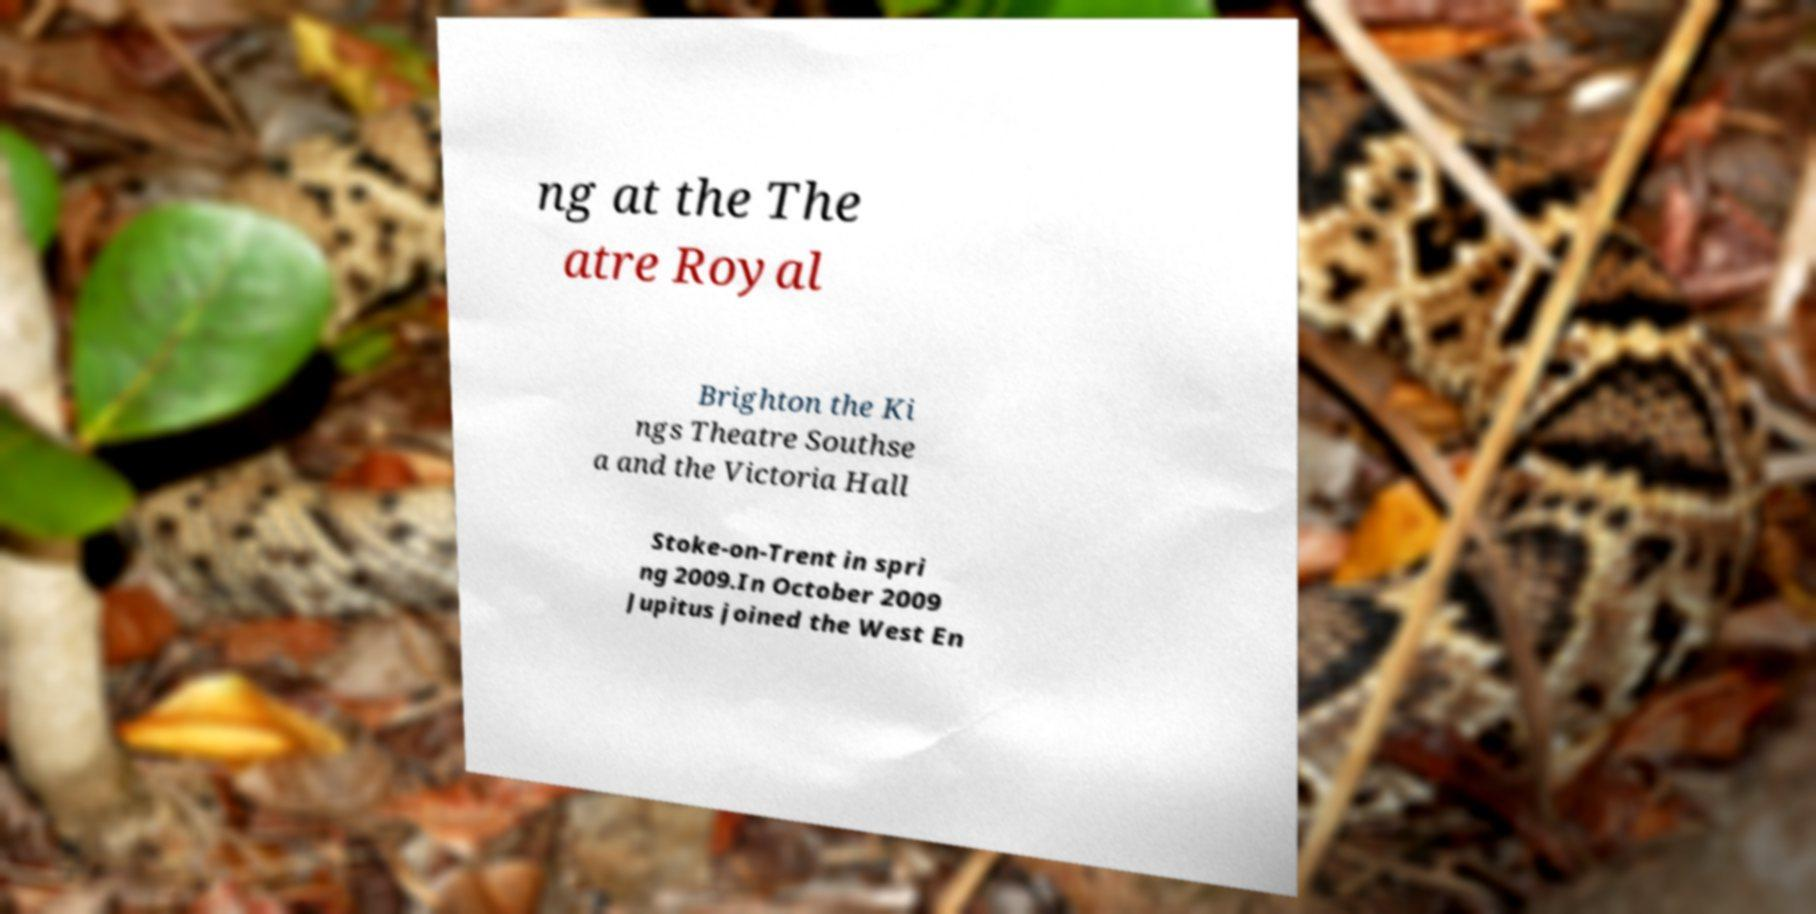I need the written content from this picture converted into text. Can you do that? ng at the The atre Royal Brighton the Ki ngs Theatre Southse a and the Victoria Hall Stoke-on-Trent in spri ng 2009.In October 2009 Jupitus joined the West En 